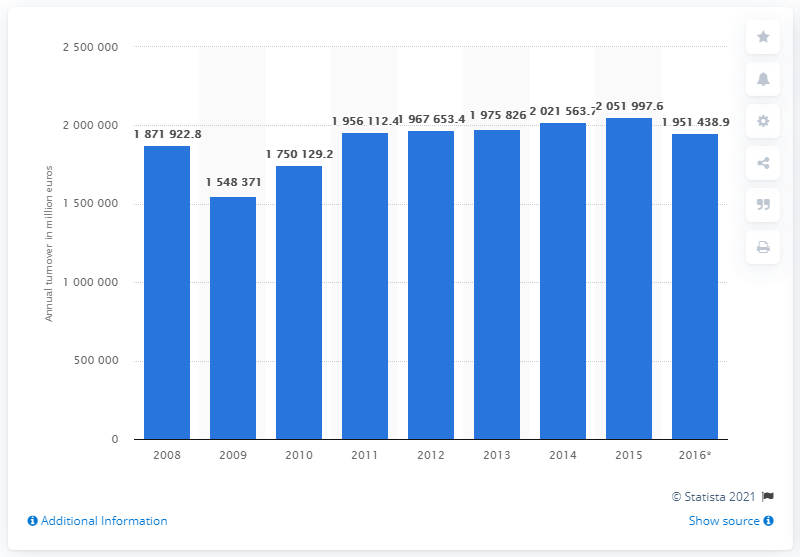Give some essential details in this illustration. In 2015, the manufacturing industry in Germany had a total turnover of 205,199,760 euros. 